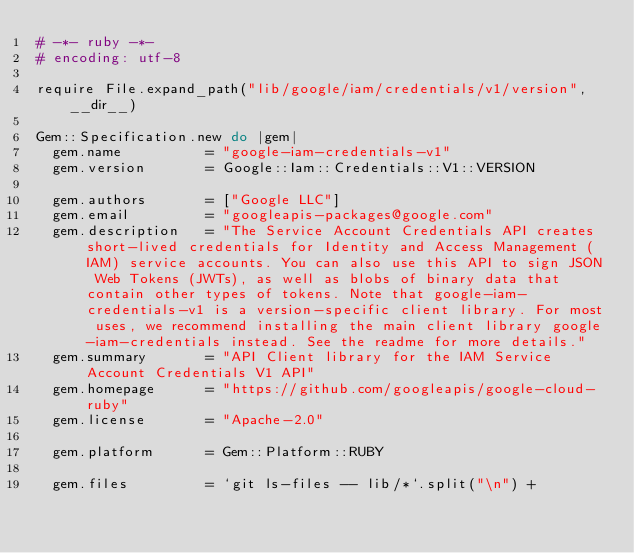<code> <loc_0><loc_0><loc_500><loc_500><_Ruby_># -*- ruby -*-
# encoding: utf-8

require File.expand_path("lib/google/iam/credentials/v1/version", __dir__)

Gem::Specification.new do |gem|
  gem.name          = "google-iam-credentials-v1"
  gem.version       = Google::Iam::Credentials::V1::VERSION

  gem.authors       = ["Google LLC"]
  gem.email         = "googleapis-packages@google.com"
  gem.description   = "The Service Account Credentials API creates short-lived credentials for Identity and Access Management (IAM) service accounts. You can also use this API to sign JSON Web Tokens (JWTs), as well as blobs of binary data that contain other types of tokens. Note that google-iam-credentials-v1 is a version-specific client library. For most uses, we recommend installing the main client library google-iam-credentials instead. See the readme for more details."
  gem.summary       = "API Client library for the IAM Service Account Credentials V1 API"
  gem.homepage      = "https://github.com/googleapis/google-cloud-ruby"
  gem.license       = "Apache-2.0"

  gem.platform      = Gem::Platform::RUBY

  gem.files         = `git ls-files -- lib/*`.split("\n") +</code> 